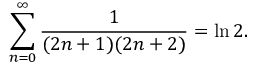Convert formula to latex. <formula><loc_0><loc_0><loc_500><loc_500>\sum _ { n = 0 } ^ { \infty } { \frac { 1 } { ( 2 n + 1 ) ( 2 n + 2 ) } } = \ln 2 .</formula> 